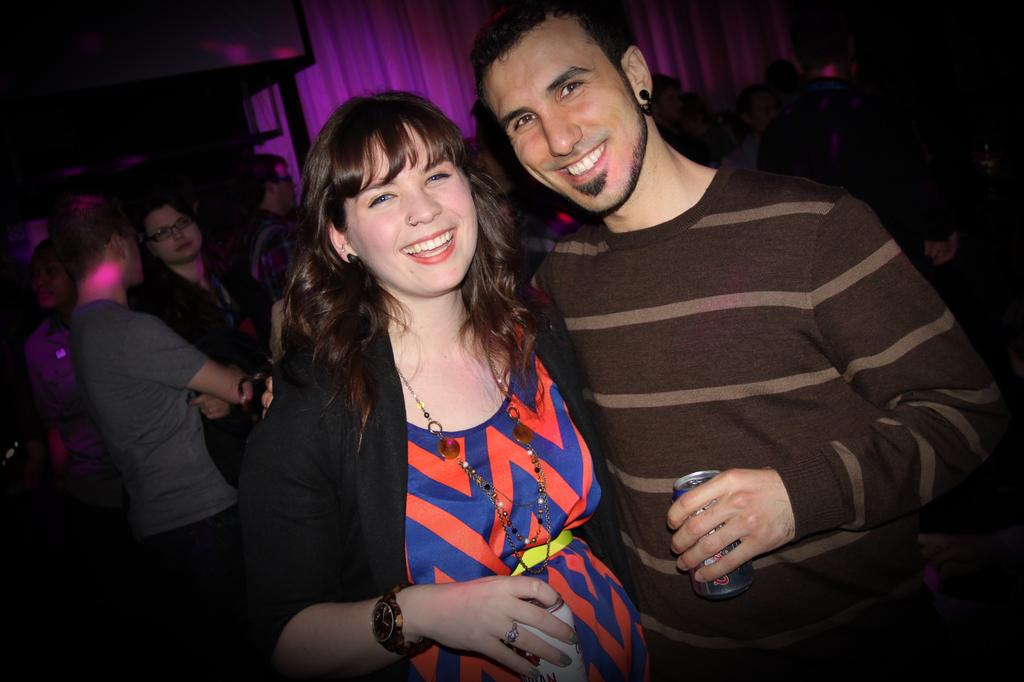How many people are present in the image? There are two persons standing in the image. What are the two persons doing in the image? The two persons are smiling and holding tins. Can you describe the people in the background of the image? There is a group of people in the background of the image. What type of pest can be seen crawling on the tins in the image? There are no pests visible in the image, and the tins are not being crawled on by any insects or animals. 